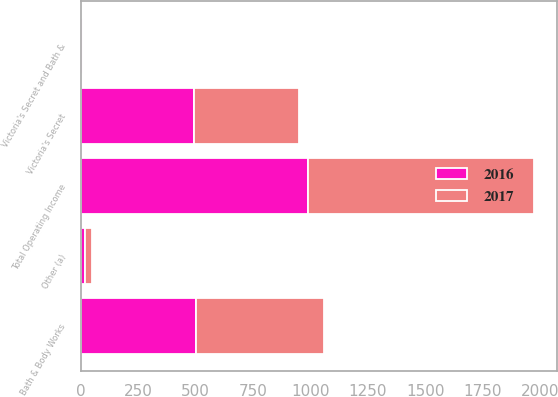Convert chart. <chart><loc_0><loc_0><loc_500><loc_500><stacked_bar_chart><ecel><fcel>Victoria's Secret<fcel>Bath & Body Works<fcel>Victoria's Secret and Bath &<fcel>Other (a)<fcel>Total Operating Income<nl><fcel>2017<fcel>457<fcel>557<fcel>4<fcel>31<fcel>987<nl><fcel>2016<fcel>494<fcel>502<fcel>10<fcel>18<fcel>988<nl></chart> 